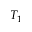Convert formula to latex. <formula><loc_0><loc_0><loc_500><loc_500>T _ { 1 }</formula> 